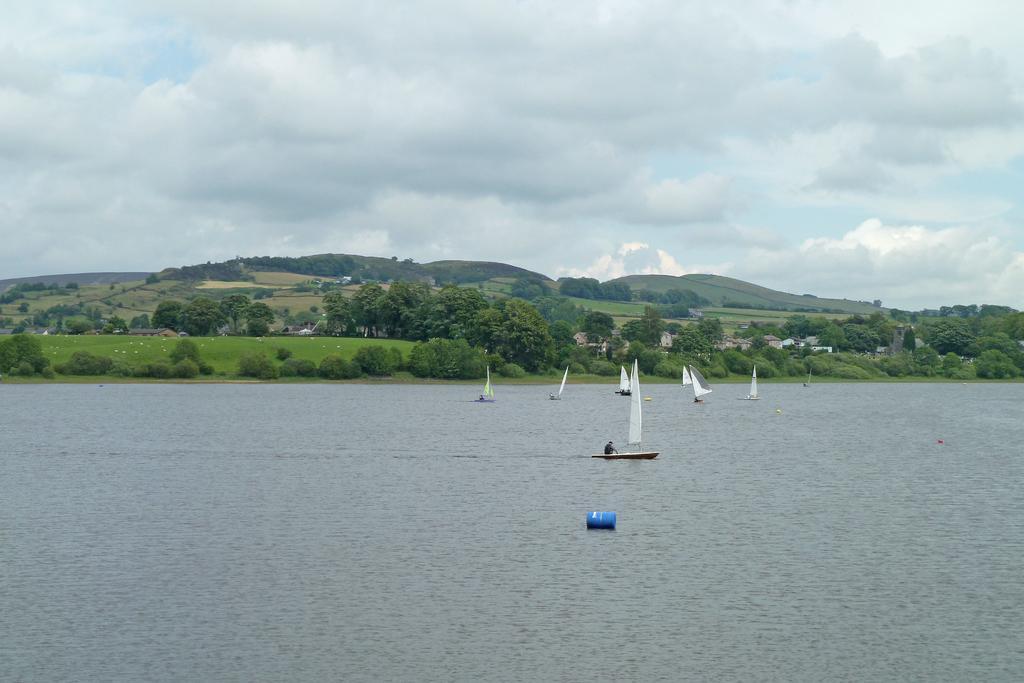Please provide a concise description of this image. In this image there is water and we can see boats on the water. In the background there are trees, hills, sheds and sky. 